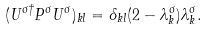<formula> <loc_0><loc_0><loc_500><loc_500>( U ^ { \sigma \dagger } P ^ { \sigma } U ^ { \sigma } ) _ { k l } = \delta _ { k l } ( 2 - \lambda _ { k } ^ { \sigma } ) \lambda _ { k } ^ { \sigma } .</formula> 